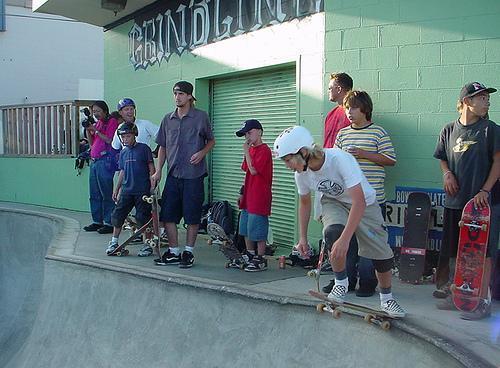How many people wearing helmet?
Give a very brief answer. 3. How many skateboards are there?
Give a very brief answer. 2. How many people are there?
Give a very brief answer. 7. 